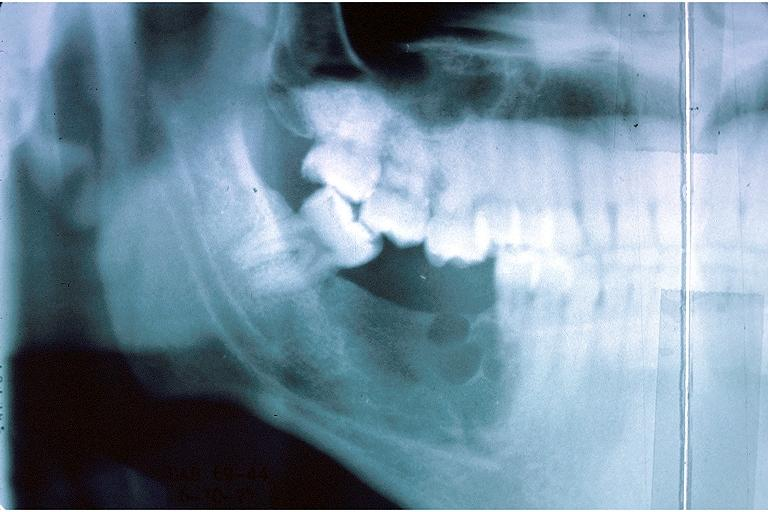does this image show ameloblastic fibroma?
Answer the question using a single word or phrase. Yes 